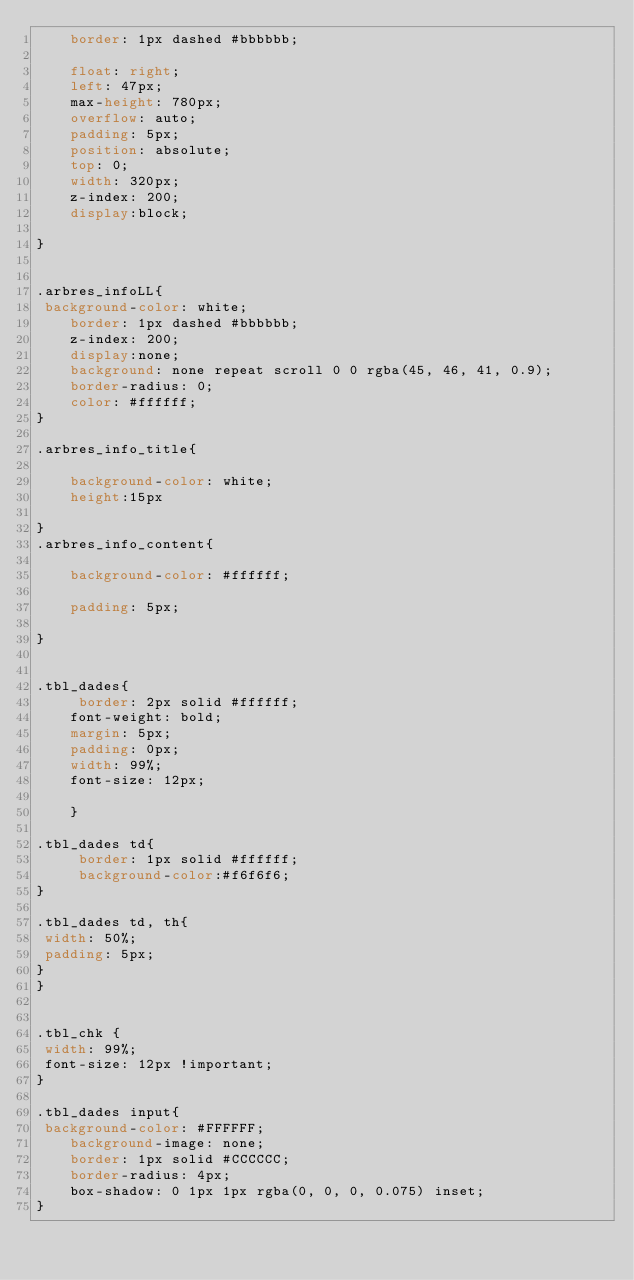<code> <loc_0><loc_0><loc_500><loc_500><_CSS_>    border: 1px dashed #bbbbbb;
 
    float: right;
    left: 47px;
    max-height: 780px;
    overflow: auto;
    padding: 5px;
    position: absolute;
    top: 0;
    width: 320px;
    z-index: 200;
    display:block;
	
}


.arbres_infoLL{
 background-color: white;
    border: 1px dashed #bbbbbb;
    z-index: 200;
    display:none;
	background: none repeat scroll 0 0 rgba(45, 46, 41, 0.9);
    border-radius: 0;
    color: #ffffff;
}

.arbres_info_title{
	
	background-color: white;
	height:15px
	
}
.arbres_info_content{
	
	background-color: #ffffff;
	
    padding: 5px;
	
}


.tbl_dades{
	 border: 2px solid #ffffff;
    font-weight: bold;
    margin: 5px;
    padding: 0px;
    width: 99%;
	font-size: 12px;
	
	}

.tbl_dades td{
	 border: 1px solid #ffffff;
	 background-color:#f6f6f6;
}	
	
.tbl_dades td, th{
 width: 50%;
 padding: 5px;
}
}


.tbl_chk {
 width: 99%;
 font-size: 12px !important;
}

.tbl_dades input{
 background-color: #FFFFFF;
    background-image: none;
    border: 1px solid #CCCCCC;
    border-radius: 4px;
    box-shadow: 0 1px 1px rgba(0, 0, 0, 0.075) inset;
}</code> 